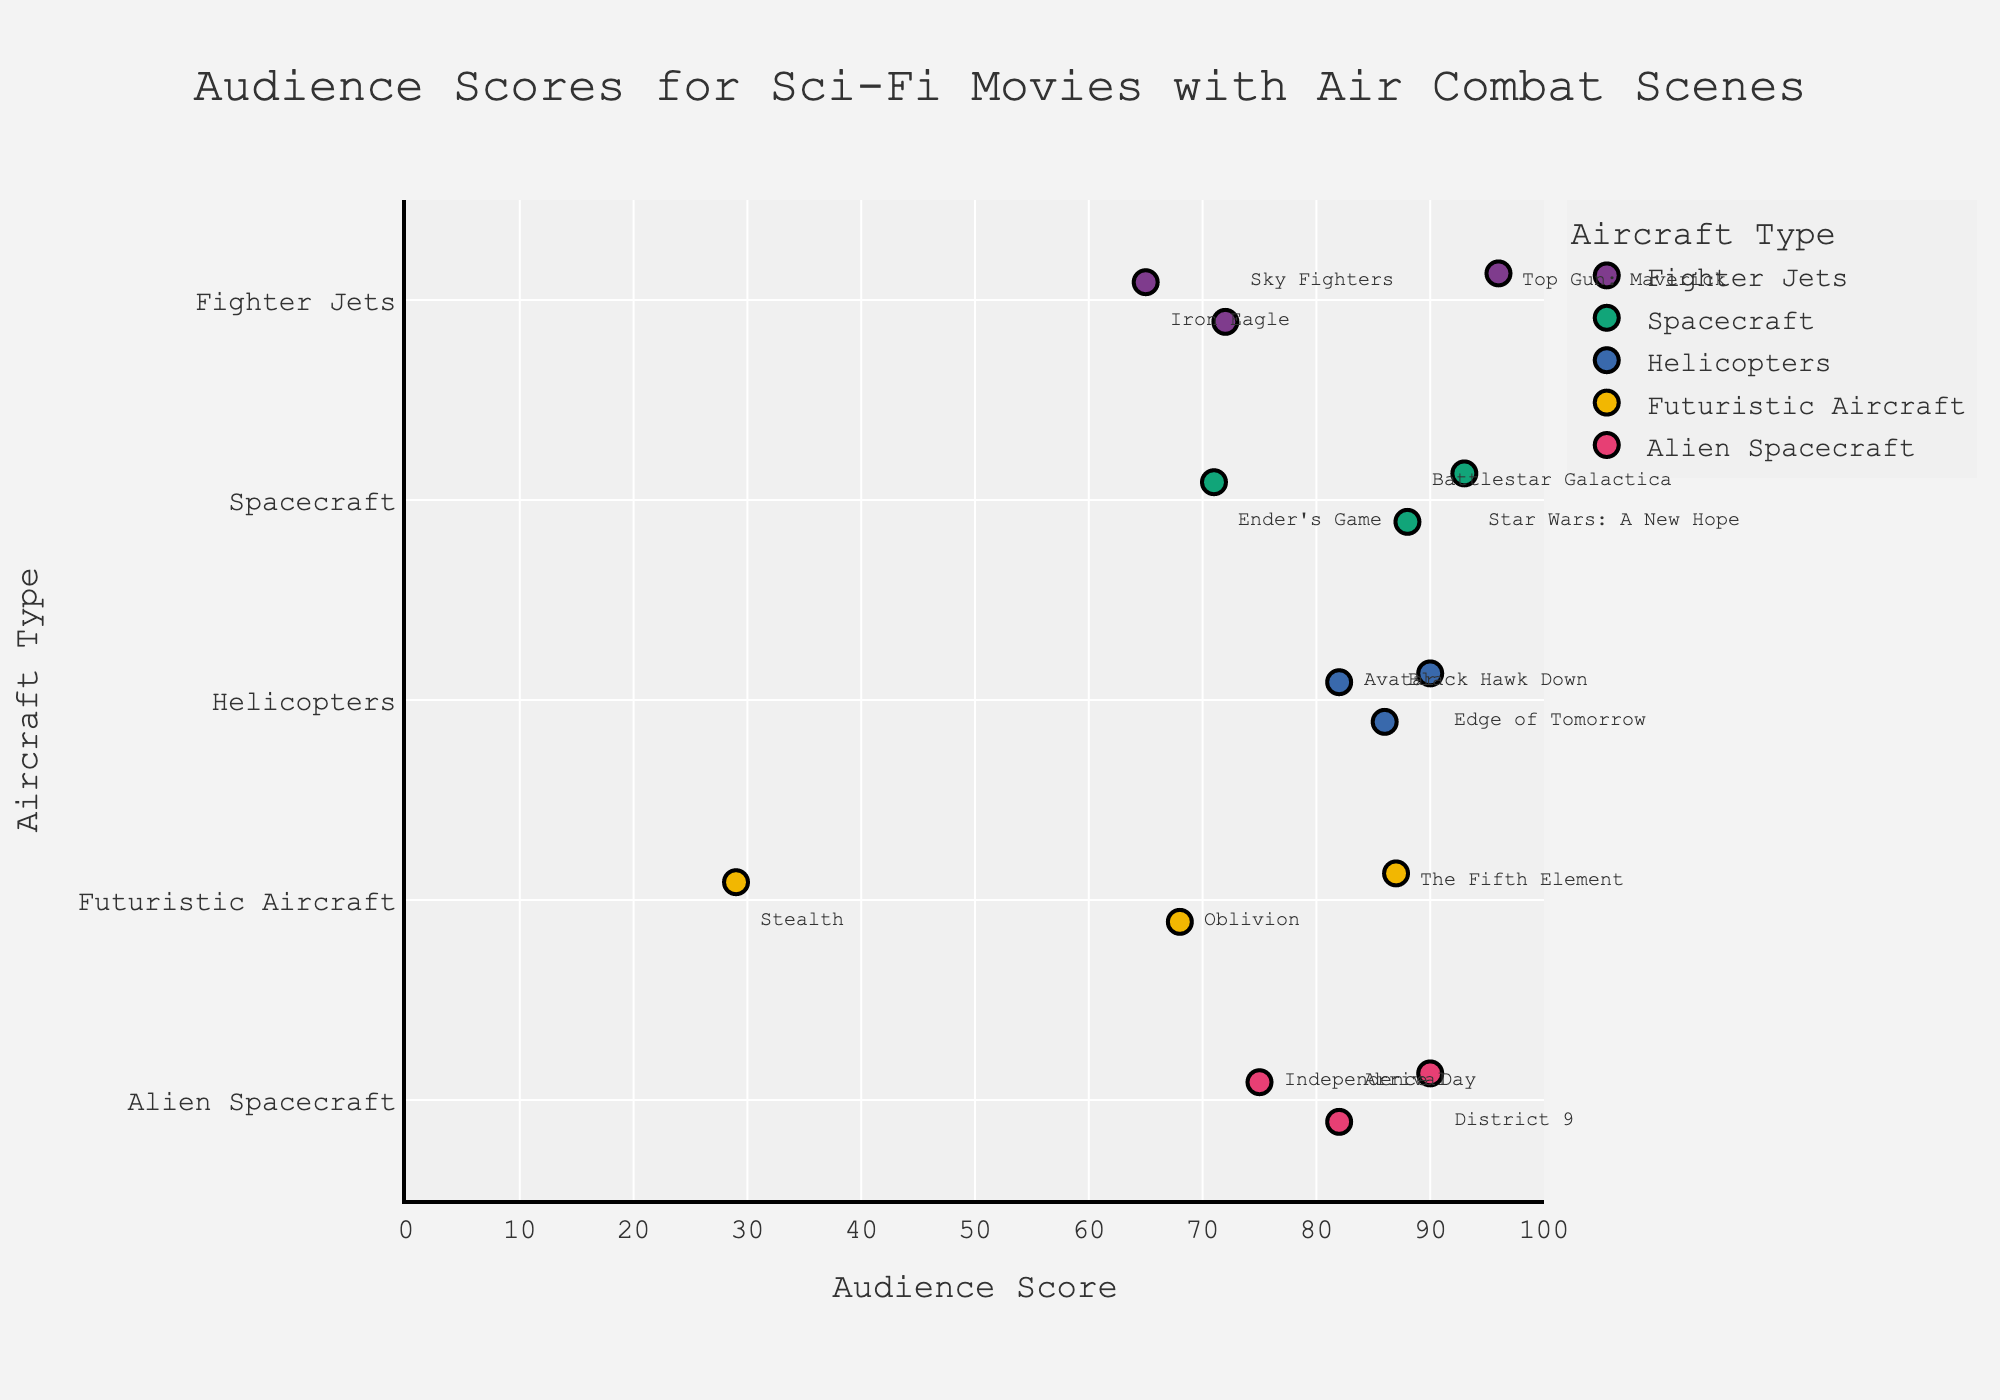What is the title of the plot? The title of the plot is usually displayed prominently at the top of the figure. In this case, the title provided in the code is "Audience Scores for Sci-Fi Movies with Air Combat Scenes."
Answer: Audience Scores for Sci-Fi Movies with Air Combat Scenes Which aircraft type has the highest audience score? To find the highest audience score, look for the point farthest to the right on the x-axis. The highest score is 96, and it is associated with "Fighter Jets."
Answer: Fighter Jets How many movies featuring Helicopters are in the plot? Count the number of data points in the Helicopters category on the y-axis. From the data, there are three movies: "Avatar," "Edge of Tomorrow," and "Black Hawk Down."
Answer: 3 What is the average audience score for movies featuring Spacecraft? Add the audience scores for all Spacecraft movies (93, 88, 71) and divide by the number of movies. The calculation is (93 + 88 + 71) / 3.
Answer: 84 Which movie had the lowest audience score, and what was its score? Identify the data point closest to 0 on the x-axis. The lowest score is 29, associated with the movie "Stealth."
Answer: Stealth, 29 What is the range of audience scores for Alien Spacecraft movies? Find the highest and lowest scores within the Alien Spacecraft category and subtract the lowest from the highest. The scores are 90 and 75, so the range is 90 - 75.
Answer: 15 Between Fighter Jets and Futuristic Aircraft, which category has a higher average audience score? Calculate the average for both categories. Fighter Jets: (96 + 65 + 72) / 3 = 77.67. Futuristic Aircraft: (68 + 87 + 29) / 3 = 61.33.
Answer: Fighter Jets Which type of aircraft has the most data points in the plot? Count the number of data points for each category. The maximum count is for Alien Spacecraft (3 movies).
Answer: Alien Spacecraft Are there any categories where all movies have audience scores above 80? Look for categories where every data point on the x-axis is above 80. Helicopters (scores of 82, 90, 86) is the category meeting this criterion.
Answer: Helicopters 